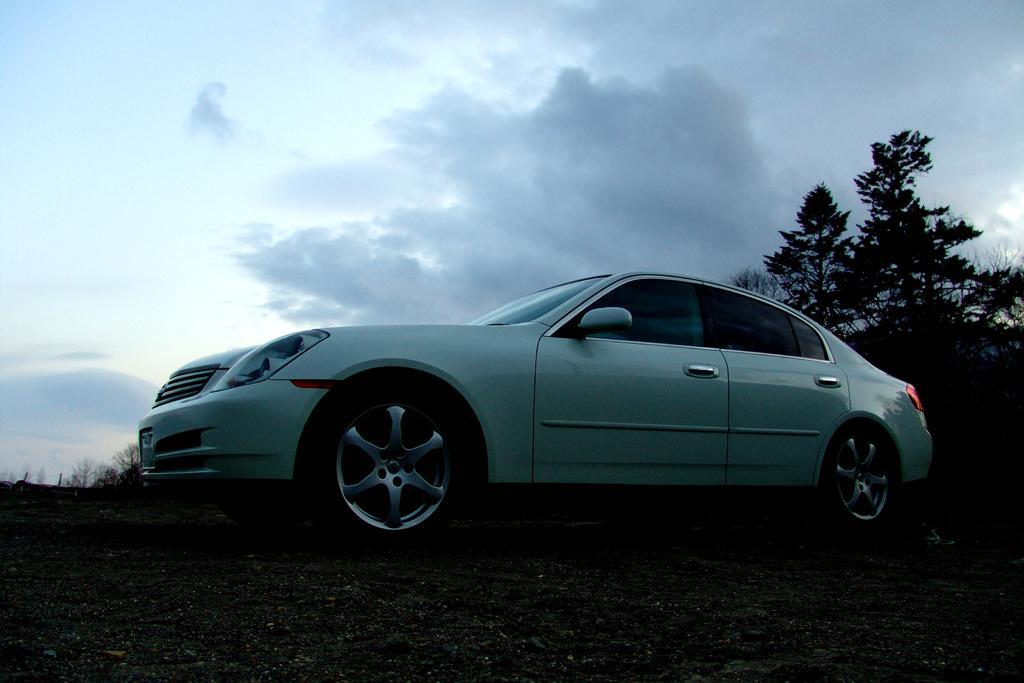Please provide a concise description of this image. In this image we can see a vehicle on the ground, there are some trees and in the background we can see the sky with clouds. 